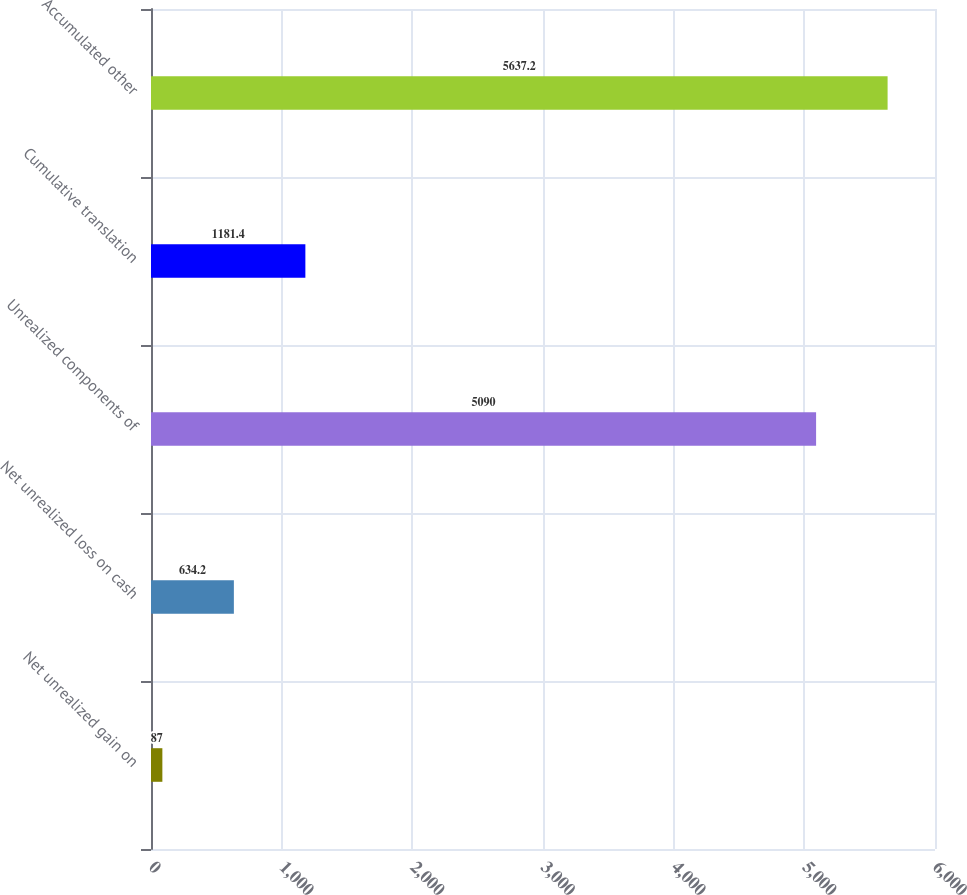Convert chart to OTSL. <chart><loc_0><loc_0><loc_500><loc_500><bar_chart><fcel>Net unrealized gain on<fcel>Net unrealized loss on cash<fcel>Unrealized components of<fcel>Cumulative translation<fcel>Accumulated other<nl><fcel>87<fcel>634.2<fcel>5090<fcel>1181.4<fcel>5637.2<nl></chart> 